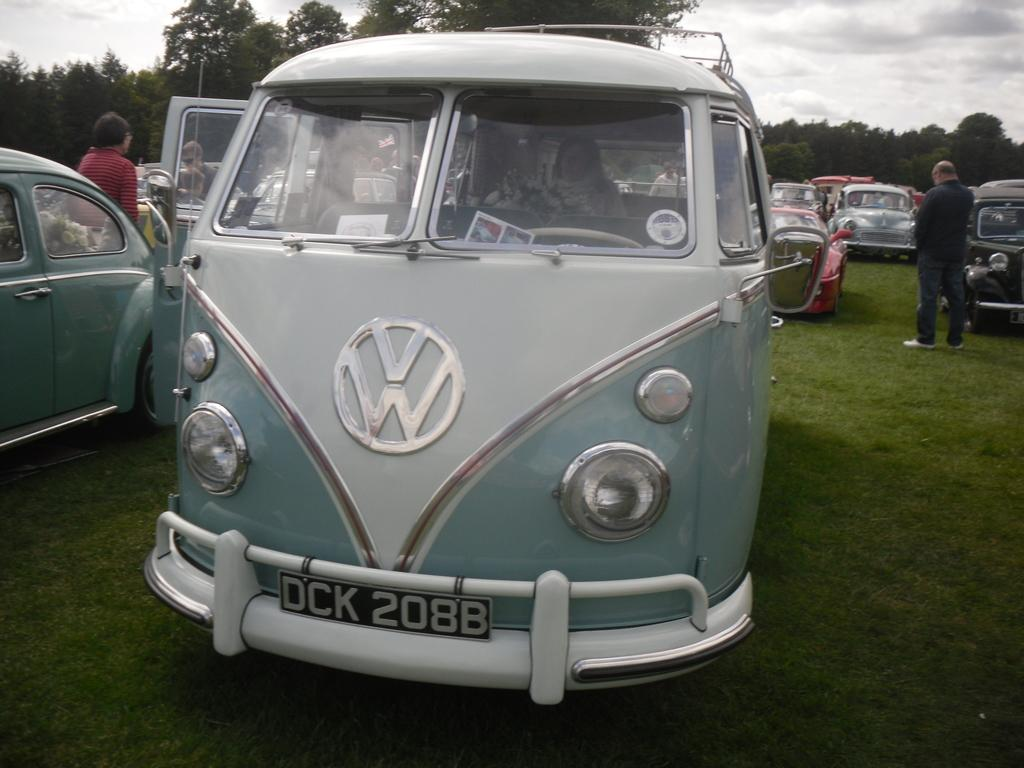<image>
Present a compact description of the photo's key features. A car show with a Volkswagon van with license plate DCK 208B. 